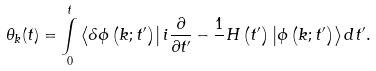<formula> <loc_0><loc_0><loc_500><loc_500>\theta _ { k } ( t ) = \underset { 0 } { \overset { t } { \int } } \left \langle \delta \phi \left ( k ; t ^ { \prime } \right ) \right | i \frac { \partial } { \partial t ^ { \prime } } - \frac { 1 } { } H \left ( t ^ { \prime } \right ) \left | \phi \left ( k ; t ^ { \prime } \right ) \right \rangle d t ^ { \prime } .</formula> 